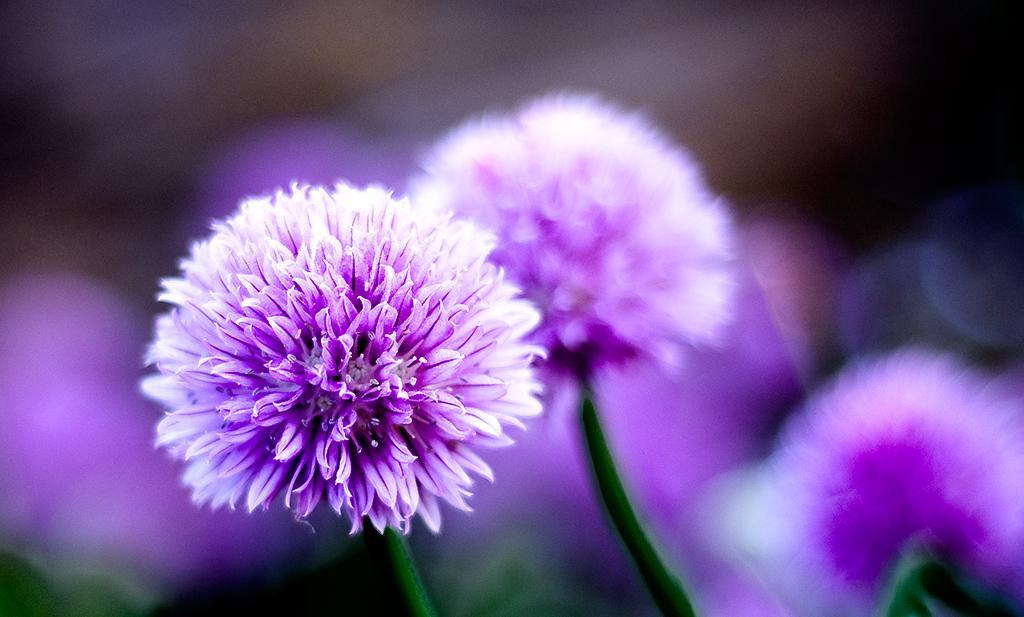Describe this image in one or two sentences. In this picture we can see the flowers. In the background, the image is blurred. 